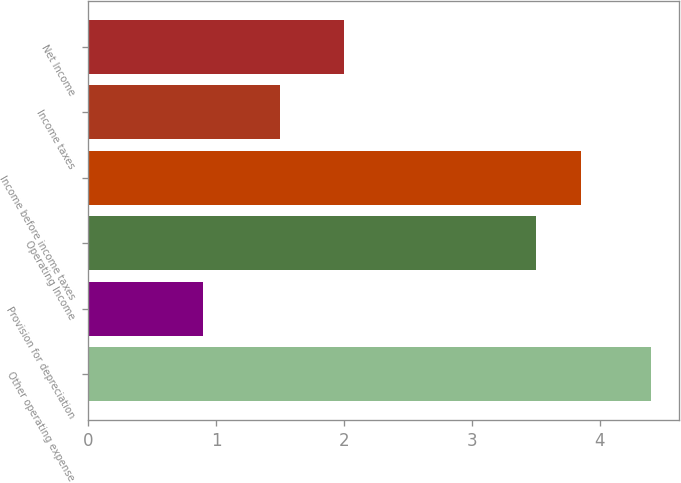<chart> <loc_0><loc_0><loc_500><loc_500><bar_chart><fcel>Other operating expense<fcel>Provision for depreciation<fcel>Operating Income<fcel>Income before income taxes<fcel>Income taxes<fcel>Net Income<nl><fcel>4.4<fcel>0.9<fcel>3.5<fcel>3.85<fcel>1.5<fcel>2<nl></chart> 